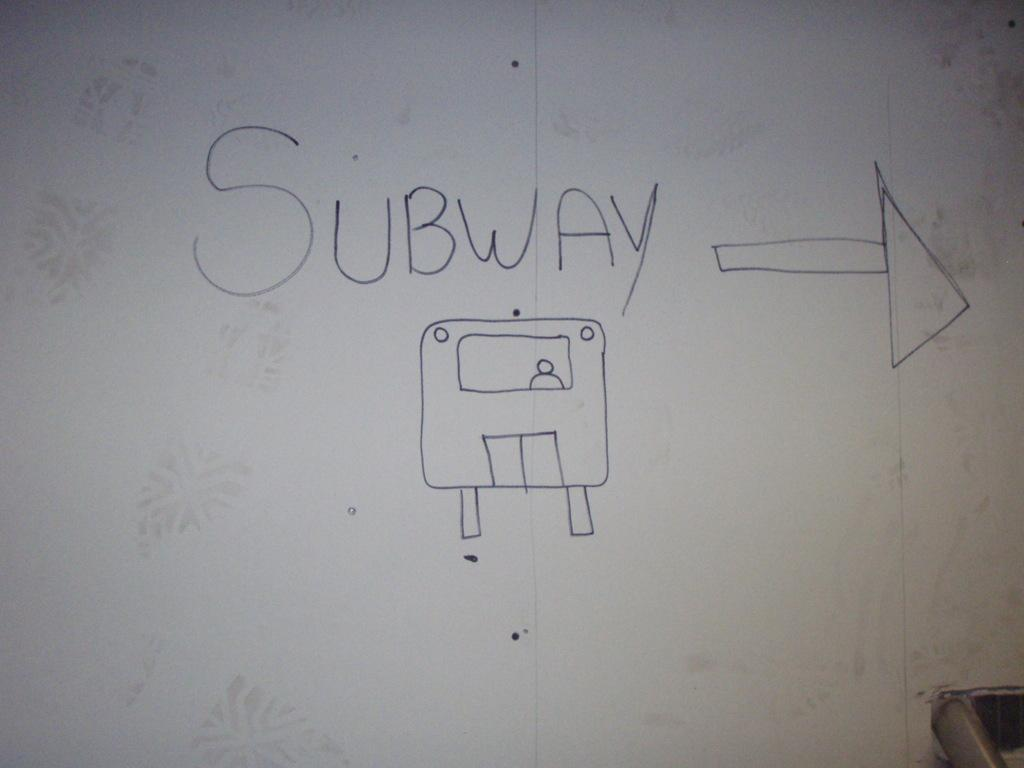<image>
Render a clear and concise summary of the photo. A subway train with a person inside it and an arrow showing the way. 